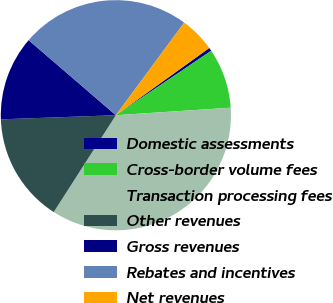Convert chart to OTSL. <chart><loc_0><loc_0><loc_500><loc_500><pie_chart><fcel>Domestic assessments<fcel>Cross-border volume fees<fcel>Transaction processing fees<fcel>Other revenues<fcel>Gross revenues<fcel>Rebates and incentives<fcel>Net revenues<nl><fcel>0.47%<fcel>8.42%<fcel>35.12%<fcel>15.35%<fcel>11.88%<fcel>23.81%<fcel>4.95%<nl></chart> 